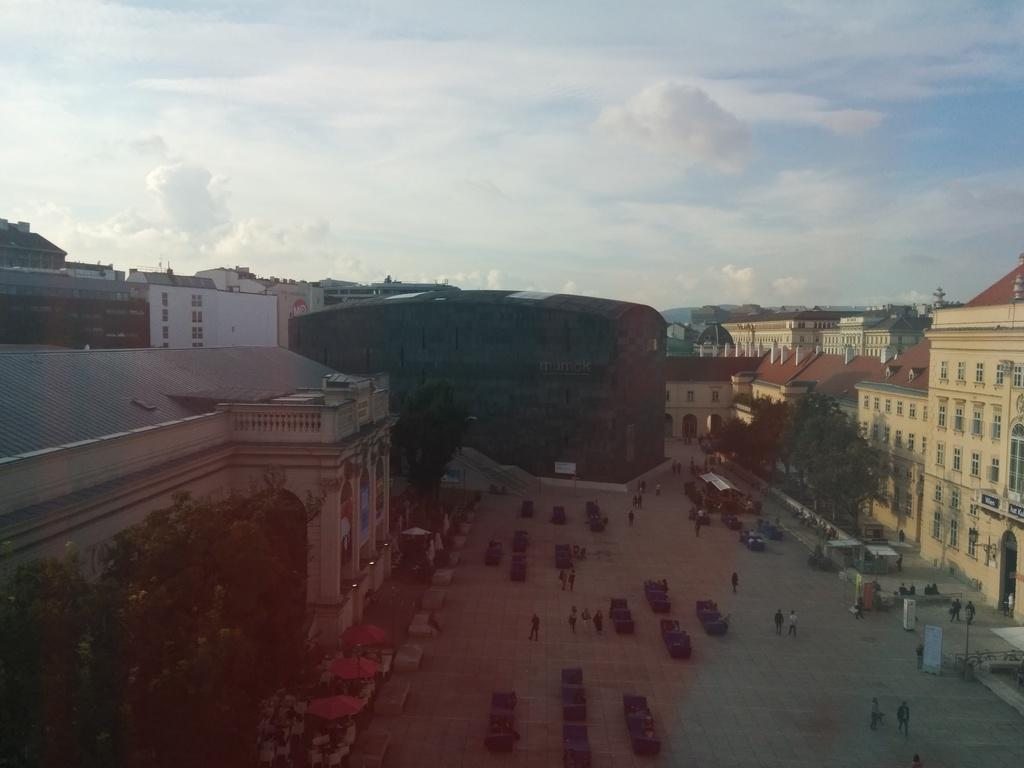What type of structures can be seen in the image? There are buildings in the image. Who or what else is present in the image? There are people standing and walking in the image. What type of vegetation is visible in the image? There are trees in the image. How would you describe the sky in the image? The sky is blue and cloudy in the image. What type of bath can be seen in the image? There is no bath present in the image. What kind of feast is being prepared in the image? There is no feast or preparation for a feast visible in the image. 